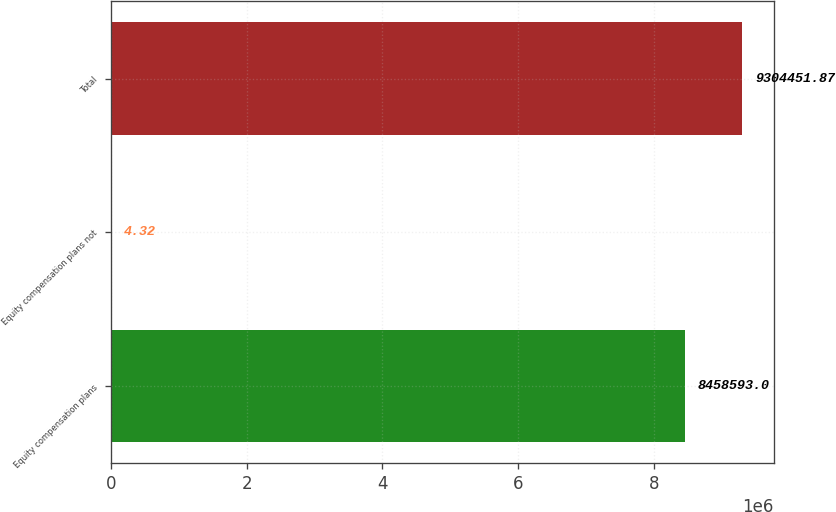Convert chart. <chart><loc_0><loc_0><loc_500><loc_500><bar_chart><fcel>Equity compensation plans<fcel>Equity compensation plans not<fcel>Total<nl><fcel>8.45859e+06<fcel>4.32<fcel>9.30445e+06<nl></chart> 